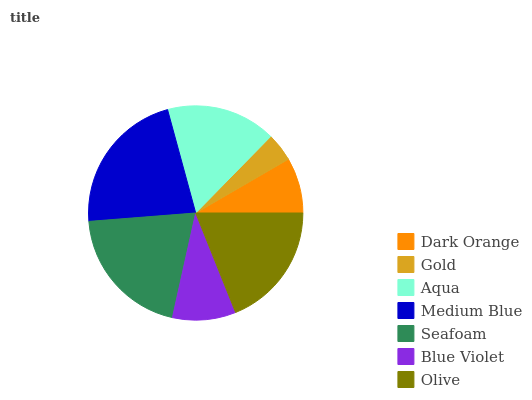Is Gold the minimum?
Answer yes or no. Yes. Is Medium Blue the maximum?
Answer yes or no. Yes. Is Aqua the minimum?
Answer yes or no. No. Is Aqua the maximum?
Answer yes or no. No. Is Aqua greater than Gold?
Answer yes or no. Yes. Is Gold less than Aqua?
Answer yes or no. Yes. Is Gold greater than Aqua?
Answer yes or no. No. Is Aqua less than Gold?
Answer yes or no. No. Is Aqua the high median?
Answer yes or no. Yes. Is Aqua the low median?
Answer yes or no. Yes. Is Gold the high median?
Answer yes or no. No. Is Seafoam the low median?
Answer yes or no. No. 